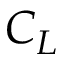<formula> <loc_0><loc_0><loc_500><loc_500>C _ { L }</formula> 